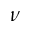<formula> <loc_0><loc_0><loc_500><loc_500>\nu</formula> 